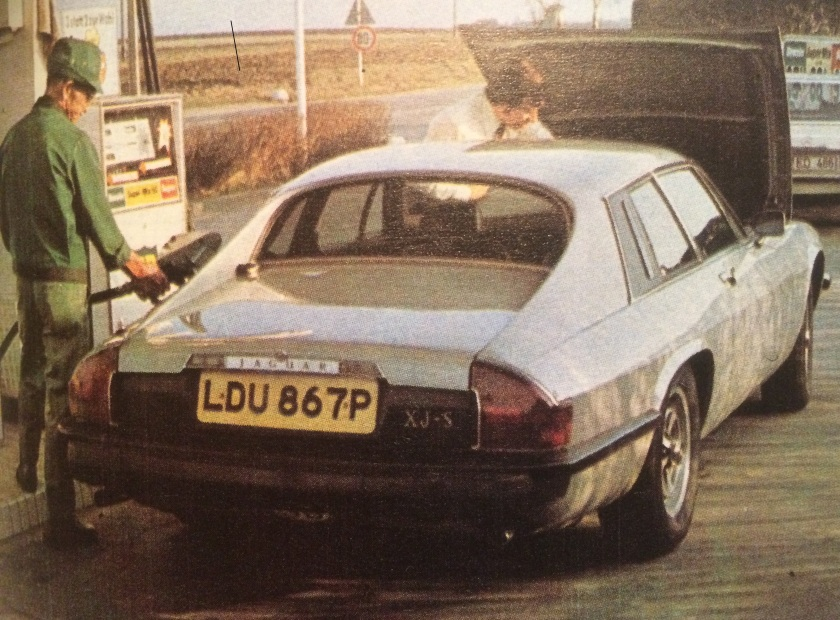Based on the visible elements in the image, can we deduce the approximate era or year in which this photograph might have been taken? The Jaguar XJ-S car model provides a significant clue, as this model was produced between 1975 and 1996. The license plate format with a suffix letter was used in the UK between 1963 and 1983, with the 'P' suffix indicating the car was registered in the year 1975 or 1976. Additionally, the design of the gas pump and the attendant's attire reflect styles from the mid-20th century. Considering these various elements—the car model, the license plate style, the gas pump design, and the mid-20th-century attire of the attendant—it is reasonable to deduce that the photograph was taken in the late 1970s. 